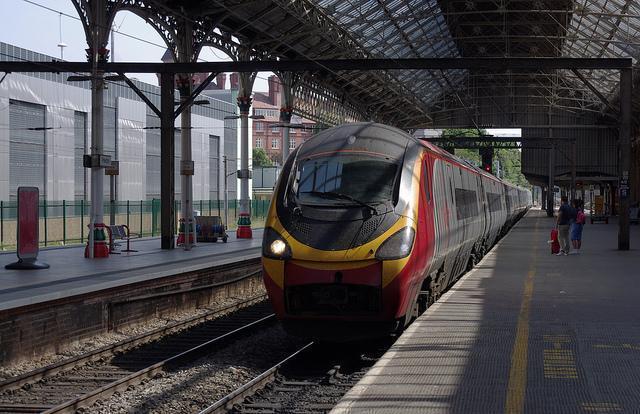Why are the people standing behind the yellow line?
Answer the question by selecting the correct answer among the 4 following choices and explain your choice with a short sentence. The answer should be formatted with the following format: `Answer: choice
Rationale: rationale.`
Options: Fun, safety, work, punishment. Answer: safety.
Rationale: The lines are for visibility. 